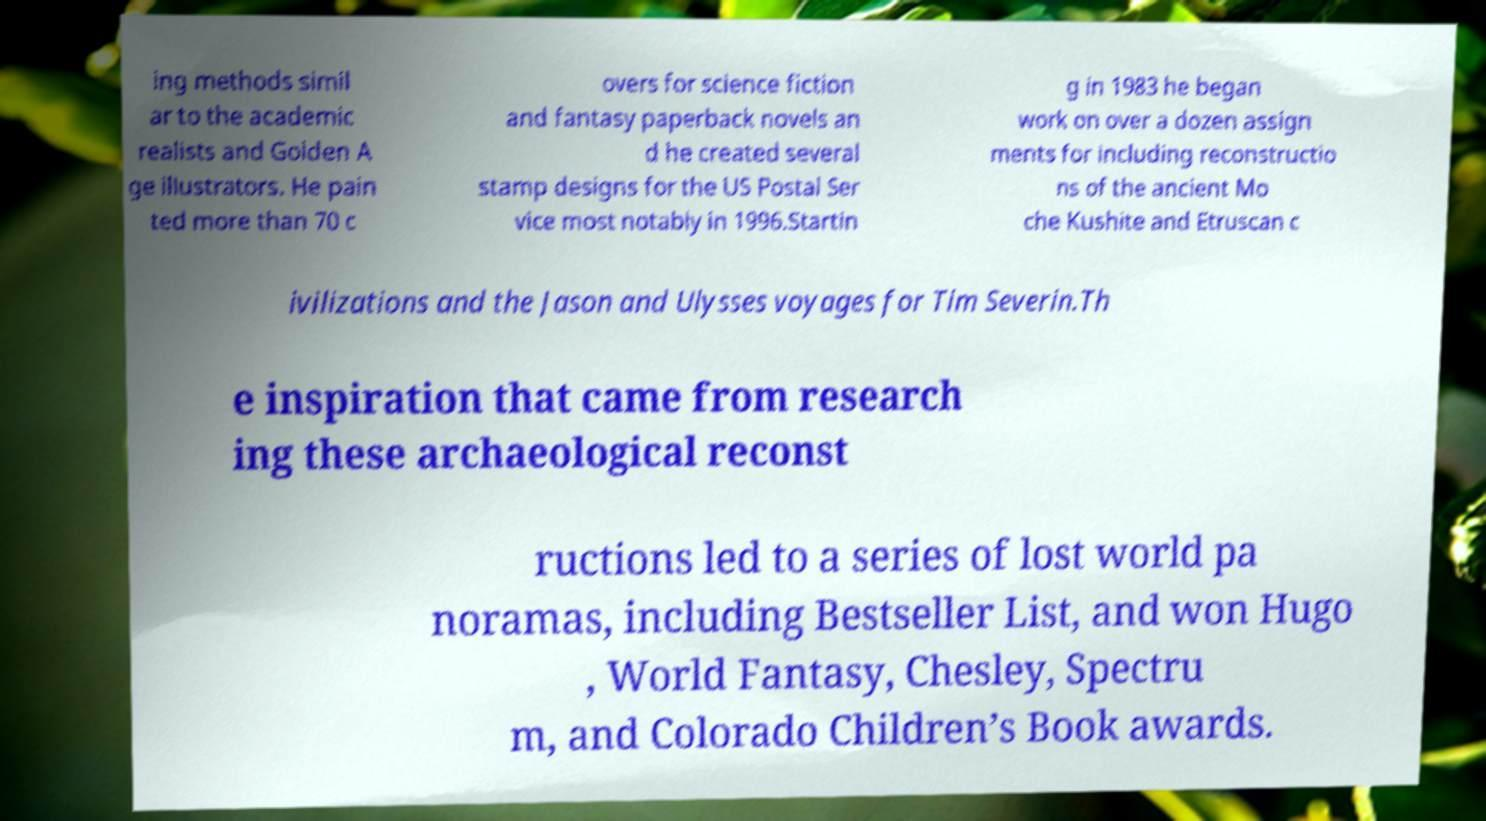Can you read and provide the text displayed in the image?This photo seems to have some interesting text. Can you extract and type it out for me? ing methods simil ar to the academic realists and Golden A ge illustrators. He pain ted more than 70 c overs for science fiction and fantasy paperback novels an d he created several stamp designs for the US Postal Ser vice most notably in 1996.Startin g in 1983 he began work on over a dozen assign ments for including reconstructio ns of the ancient Mo che Kushite and Etruscan c ivilizations and the Jason and Ulysses voyages for Tim Severin.Th e inspiration that came from research ing these archaeological reconst ructions led to a series of lost world pa noramas, including Bestseller List, and won Hugo , World Fantasy, Chesley, Spectru m, and Colorado Children’s Book awards. 